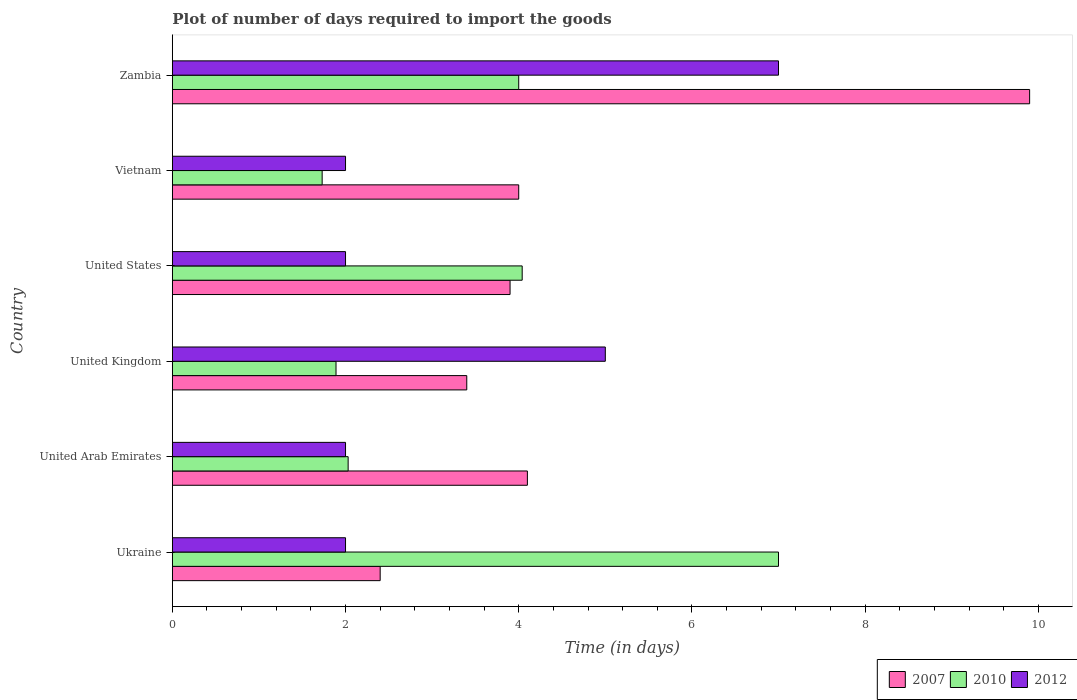How many different coloured bars are there?
Offer a very short reply. 3. How many groups of bars are there?
Make the answer very short. 6. How many bars are there on the 4th tick from the bottom?
Keep it short and to the point. 3. Across all countries, what is the maximum time required to import goods in 2012?
Your response must be concise. 7. Across all countries, what is the minimum time required to import goods in 2010?
Provide a succinct answer. 1.73. In which country was the time required to import goods in 2007 maximum?
Ensure brevity in your answer.  Zambia. In which country was the time required to import goods in 2012 minimum?
Offer a very short reply. Ukraine. What is the total time required to import goods in 2010 in the graph?
Make the answer very short. 20.69. What is the difference between the time required to import goods in 2007 in Ukraine and that in United Arab Emirates?
Keep it short and to the point. -1.7. What is the difference between the time required to import goods in 2012 in Ukraine and the time required to import goods in 2010 in Zambia?
Keep it short and to the point. -2. What is the average time required to import goods in 2012 per country?
Provide a short and direct response. 3.33. What is the difference between the time required to import goods in 2010 and time required to import goods in 2012 in Ukraine?
Offer a very short reply. 5. What is the ratio of the time required to import goods in 2010 in United Arab Emirates to that in United Kingdom?
Your answer should be compact. 1.07. Is the difference between the time required to import goods in 2010 in United States and Vietnam greater than the difference between the time required to import goods in 2012 in United States and Vietnam?
Your answer should be compact. Yes. What is the difference between the highest and the second highest time required to import goods in 2012?
Your answer should be compact. 2. What does the 1st bar from the top in United States represents?
Your response must be concise. 2012. What does the 2nd bar from the bottom in Ukraine represents?
Your response must be concise. 2010. How many bars are there?
Your answer should be compact. 18. How many countries are there in the graph?
Provide a succinct answer. 6. How many legend labels are there?
Make the answer very short. 3. How are the legend labels stacked?
Offer a terse response. Horizontal. What is the title of the graph?
Keep it short and to the point. Plot of number of days required to import the goods. Does "2004" appear as one of the legend labels in the graph?
Your answer should be compact. No. What is the label or title of the X-axis?
Your answer should be very brief. Time (in days). What is the label or title of the Y-axis?
Make the answer very short. Country. What is the Time (in days) of 2010 in United Arab Emirates?
Offer a terse response. 2.03. What is the Time (in days) in 2012 in United Arab Emirates?
Give a very brief answer. 2. What is the Time (in days) of 2010 in United Kingdom?
Make the answer very short. 1.89. What is the Time (in days) of 2007 in United States?
Your response must be concise. 3.9. What is the Time (in days) of 2010 in United States?
Offer a terse response. 4.04. What is the Time (in days) of 2012 in United States?
Offer a very short reply. 2. What is the Time (in days) in 2007 in Vietnam?
Offer a very short reply. 4. What is the Time (in days) in 2010 in Vietnam?
Your answer should be very brief. 1.73. What is the Time (in days) in 2012 in Vietnam?
Give a very brief answer. 2. Across all countries, what is the maximum Time (in days) of 2007?
Keep it short and to the point. 9.9. Across all countries, what is the maximum Time (in days) in 2012?
Make the answer very short. 7. Across all countries, what is the minimum Time (in days) of 2007?
Provide a short and direct response. 2.4. Across all countries, what is the minimum Time (in days) of 2010?
Offer a terse response. 1.73. Across all countries, what is the minimum Time (in days) of 2012?
Your answer should be very brief. 2. What is the total Time (in days) in 2007 in the graph?
Your response must be concise. 27.7. What is the total Time (in days) of 2010 in the graph?
Your answer should be compact. 20.69. What is the total Time (in days) of 2012 in the graph?
Your response must be concise. 20. What is the difference between the Time (in days) in 2007 in Ukraine and that in United Arab Emirates?
Your answer should be very brief. -1.7. What is the difference between the Time (in days) of 2010 in Ukraine and that in United Arab Emirates?
Keep it short and to the point. 4.97. What is the difference between the Time (in days) of 2012 in Ukraine and that in United Arab Emirates?
Ensure brevity in your answer.  0. What is the difference between the Time (in days) of 2010 in Ukraine and that in United Kingdom?
Ensure brevity in your answer.  5.11. What is the difference between the Time (in days) of 2007 in Ukraine and that in United States?
Ensure brevity in your answer.  -1.5. What is the difference between the Time (in days) in 2010 in Ukraine and that in United States?
Make the answer very short. 2.96. What is the difference between the Time (in days) in 2012 in Ukraine and that in United States?
Ensure brevity in your answer.  0. What is the difference between the Time (in days) in 2007 in Ukraine and that in Vietnam?
Your answer should be very brief. -1.6. What is the difference between the Time (in days) of 2010 in Ukraine and that in Vietnam?
Provide a succinct answer. 5.27. What is the difference between the Time (in days) in 2007 in United Arab Emirates and that in United Kingdom?
Provide a short and direct response. 0.7. What is the difference between the Time (in days) of 2010 in United Arab Emirates and that in United Kingdom?
Provide a short and direct response. 0.14. What is the difference between the Time (in days) of 2010 in United Arab Emirates and that in United States?
Give a very brief answer. -2.01. What is the difference between the Time (in days) of 2012 in United Arab Emirates and that in United States?
Your response must be concise. 0. What is the difference between the Time (in days) in 2012 in United Arab Emirates and that in Vietnam?
Ensure brevity in your answer.  0. What is the difference between the Time (in days) of 2010 in United Arab Emirates and that in Zambia?
Ensure brevity in your answer.  -1.97. What is the difference between the Time (in days) of 2010 in United Kingdom and that in United States?
Ensure brevity in your answer.  -2.15. What is the difference between the Time (in days) of 2010 in United Kingdom and that in Vietnam?
Offer a very short reply. 0.16. What is the difference between the Time (in days) of 2010 in United Kingdom and that in Zambia?
Your answer should be very brief. -2.11. What is the difference between the Time (in days) in 2007 in United States and that in Vietnam?
Offer a terse response. -0.1. What is the difference between the Time (in days) of 2010 in United States and that in Vietnam?
Your answer should be compact. 2.31. What is the difference between the Time (in days) in 2007 in United States and that in Zambia?
Give a very brief answer. -6. What is the difference between the Time (in days) of 2010 in United States and that in Zambia?
Ensure brevity in your answer.  0.04. What is the difference between the Time (in days) of 2010 in Vietnam and that in Zambia?
Keep it short and to the point. -2.27. What is the difference between the Time (in days) of 2012 in Vietnam and that in Zambia?
Offer a very short reply. -5. What is the difference between the Time (in days) in 2007 in Ukraine and the Time (in days) in 2010 in United Arab Emirates?
Your response must be concise. 0.37. What is the difference between the Time (in days) in 2007 in Ukraine and the Time (in days) in 2012 in United Arab Emirates?
Your answer should be compact. 0.4. What is the difference between the Time (in days) in 2007 in Ukraine and the Time (in days) in 2010 in United Kingdom?
Give a very brief answer. 0.51. What is the difference between the Time (in days) of 2007 in Ukraine and the Time (in days) of 2012 in United Kingdom?
Make the answer very short. -2.6. What is the difference between the Time (in days) in 2007 in Ukraine and the Time (in days) in 2010 in United States?
Provide a short and direct response. -1.64. What is the difference between the Time (in days) in 2007 in Ukraine and the Time (in days) in 2010 in Vietnam?
Make the answer very short. 0.67. What is the difference between the Time (in days) in 2007 in United Arab Emirates and the Time (in days) in 2010 in United Kingdom?
Give a very brief answer. 2.21. What is the difference between the Time (in days) in 2010 in United Arab Emirates and the Time (in days) in 2012 in United Kingdom?
Your answer should be very brief. -2.97. What is the difference between the Time (in days) in 2007 in United Arab Emirates and the Time (in days) in 2010 in United States?
Provide a short and direct response. 0.06. What is the difference between the Time (in days) of 2010 in United Arab Emirates and the Time (in days) of 2012 in United States?
Your response must be concise. 0.03. What is the difference between the Time (in days) of 2007 in United Arab Emirates and the Time (in days) of 2010 in Vietnam?
Offer a terse response. 2.37. What is the difference between the Time (in days) of 2007 in United Arab Emirates and the Time (in days) of 2012 in Vietnam?
Your answer should be compact. 2.1. What is the difference between the Time (in days) in 2010 in United Arab Emirates and the Time (in days) in 2012 in Zambia?
Provide a short and direct response. -4.97. What is the difference between the Time (in days) of 2007 in United Kingdom and the Time (in days) of 2010 in United States?
Your answer should be very brief. -0.64. What is the difference between the Time (in days) in 2010 in United Kingdom and the Time (in days) in 2012 in United States?
Ensure brevity in your answer.  -0.11. What is the difference between the Time (in days) in 2007 in United Kingdom and the Time (in days) in 2010 in Vietnam?
Provide a succinct answer. 1.67. What is the difference between the Time (in days) in 2007 in United Kingdom and the Time (in days) in 2012 in Vietnam?
Make the answer very short. 1.4. What is the difference between the Time (in days) of 2010 in United Kingdom and the Time (in days) of 2012 in Vietnam?
Give a very brief answer. -0.11. What is the difference between the Time (in days) in 2010 in United Kingdom and the Time (in days) in 2012 in Zambia?
Give a very brief answer. -5.11. What is the difference between the Time (in days) in 2007 in United States and the Time (in days) in 2010 in Vietnam?
Give a very brief answer. 2.17. What is the difference between the Time (in days) of 2007 in United States and the Time (in days) of 2012 in Vietnam?
Your response must be concise. 1.9. What is the difference between the Time (in days) of 2010 in United States and the Time (in days) of 2012 in Vietnam?
Give a very brief answer. 2.04. What is the difference between the Time (in days) of 2007 in United States and the Time (in days) of 2012 in Zambia?
Make the answer very short. -3.1. What is the difference between the Time (in days) in 2010 in United States and the Time (in days) in 2012 in Zambia?
Provide a short and direct response. -2.96. What is the difference between the Time (in days) in 2010 in Vietnam and the Time (in days) in 2012 in Zambia?
Keep it short and to the point. -5.27. What is the average Time (in days) of 2007 per country?
Give a very brief answer. 4.62. What is the average Time (in days) in 2010 per country?
Your answer should be compact. 3.45. What is the difference between the Time (in days) of 2007 and Time (in days) of 2012 in Ukraine?
Provide a succinct answer. 0.4. What is the difference between the Time (in days) of 2010 and Time (in days) of 2012 in Ukraine?
Offer a terse response. 5. What is the difference between the Time (in days) of 2007 and Time (in days) of 2010 in United Arab Emirates?
Keep it short and to the point. 2.07. What is the difference between the Time (in days) of 2007 and Time (in days) of 2012 in United Arab Emirates?
Keep it short and to the point. 2.1. What is the difference between the Time (in days) in 2010 and Time (in days) in 2012 in United Arab Emirates?
Your answer should be compact. 0.03. What is the difference between the Time (in days) in 2007 and Time (in days) in 2010 in United Kingdom?
Give a very brief answer. 1.51. What is the difference between the Time (in days) of 2010 and Time (in days) of 2012 in United Kingdom?
Provide a short and direct response. -3.11. What is the difference between the Time (in days) in 2007 and Time (in days) in 2010 in United States?
Your response must be concise. -0.14. What is the difference between the Time (in days) in 2007 and Time (in days) in 2012 in United States?
Keep it short and to the point. 1.9. What is the difference between the Time (in days) of 2010 and Time (in days) of 2012 in United States?
Offer a terse response. 2.04. What is the difference between the Time (in days) of 2007 and Time (in days) of 2010 in Vietnam?
Provide a short and direct response. 2.27. What is the difference between the Time (in days) in 2007 and Time (in days) in 2012 in Vietnam?
Ensure brevity in your answer.  2. What is the difference between the Time (in days) of 2010 and Time (in days) of 2012 in Vietnam?
Provide a short and direct response. -0.27. What is the difference between the Time (in days) of 2007 and Time (in days) of 2010 in Zambia?
Keep it short and to the point. 5.9. What is the difference between the Time (in days) of 2007 and Time (in days) of 2012 in Zambia?
Keep it short and to the point. 2.9. What is the ratio of the Time (in days) of 2007 in Ukraine to that in United Arab Emirates?
Your answer should be compact. 0.59. What is the ratio of the Time (in days) in 2010 in Ukraine to that in United Arab Emirates?
Your answer should be compact. 3.45. What is the ratio of the Time (in days) of 2012 in Ukraine to that in United Arab Emirates?
Make the answer very short. 1. What is the ratio of the Time (in days) in 2007 in Ukraine to that in United Kingdom?
Keep it short and to the point. 0.71. What is the ratio of the Time (in days) of 2010 in Ukraine to that in United Kingdom?
Provide a short and direct response. 3.7. What is the ratio of the Time (in days) in 2007 in Ukraine to that in United States?
Your response must be concise. 0.62. What is the ratio of the Time (in days) in 2010 in Ukraine to that in United States?
Offer a terse response. 1.73. What is the ratio of the Time (in days) of 2012 in Ukraine to that in United States?
Your answer should be very brief. 1. What is the ratio of the Time (in days) of 2010 in Ukraine to that in Vietnam?
Your answer should be compact. 4.05. What is the ratio of the Time (in days) in 2007 in Ukraine to that in Zambia?
Your answer should be very brief. 0.24. What is the ratio of the Time (in days) in 2012 in Ukraine to that in Zambia?
Make the answer very short. 0.29. What is the ratio of the Time (in days) of 2007 in United Arab Emirates to that in United Kingdom?
Your answer should be compact. 1.21. What is the ratio of the Time (in days) in 2010 in United Arab Emirates to that in United Kingdom?
Offer a terse response. 1.07. What is the ratio of the Time (in days) in 2012 in United Arab Emirates to that in United Kingdom?
Make the answer very short. 0.4. What is the ratio of the Time (in days) in 2007 in United Arab Emirates to that in United States?
Provide a succinct answer. 1.05. What is the ratio of the Time (in days) in 2010 in United Arab Emirates to that in United States?
Provide a short and direct response. 0.5. What is the ratio of the Time (in days) of 2007 in United Arab Emirates to that in Vietnam?
Offer a terse response. 1.02. What is the ratio of the Time (in days) in 2010 in United Arab Emirates to that in Vietnam?
Offer a very short reply. 1.17. What is the ratio of the Time (in days) of 2012 in United Arab Emirates to that in Vietnam?
Your response must be concise. 1. What is the ratio of the Time (in days) of 2007 in United Arab Emirates to that in Zambia?
Ensure brevity in your answer.  0.41. What is the ratio of the Time (in days) in 2010 in United Arab Emirates to that in Zambia?
Offer a terse response. 0.51. What is the ratio of the Time (in days) of 2012 in United Arab Emirates to that in Zambia?
Your answer should be compact. 0.29. What is the ratio of the Time (in days) in 2007 in United Kingdom to that in United States?
Your response must be concise. 0.87. What is the ratio of the Time (in days) in 2010 in United Kingdom to that in United States?
Provide a succinct answer. 0.47. What is the ratio of the Time (in days) of 2007 in United Kingdom to that in Vietnam?
Your answer should be compact. 0.85. What is the ratio of the Time (in days) of 2010 in United Kingdom to that in Vietnam?
Your answer should be compact. 1.09. What is the ratio of the Time (in days) of 2012 in United Kingdom to that in Vietnam?
Give a very brief answer. 2.5. What is the ratio of the Time (in days) in 2007 in United Kingdom to that in Zambia?
Offer a very short reply. 0.34. What is the ratio of the Time (in days) in 2010 in United Kingdom to that in Zambia?
Provide a short and direct response. 0.47. What is the ratio of the Time (in days) in 2010 in United States to that in Vietnam?
Your answer should be compact. 2.34. What is the ratio of the Time (in days) in 2012 in United States to that in Vietnam?
Make the answer very short. 1. What is the ratio of the Time (in days) in 2007 in United States to that in Zambia?
Provide a succinct answer. 0.39. What is the ratio of the Time (in days) of 2010 in United States to that in Zambia?
Your answer should be very brief. 1.01. What is the ratio of the Time (in days) of 2012 in United States to that in Zambia?
Your answer should be compact. 0.29. What is the ratio of the Time (in days) of 2007 in Vietnam to that in Zambia?
Your response must be concise. 0.4. What is the ratio of the Time (in days) in 2010 in Vietnam to that in Zambia?
Offer a very short reply. 0.43. What is the ratio of the Time (in days) in 2012 in Vietnam to that in Zambia?
Give a very brief answer. 0.29. What is the difference between the highest and the second highest Time (in days) of 2010?
Give a very brief answer. 2.96. What is the difference between the highest and the lowest Time (in days) of 2007?
Make the answer very short. 7.5. What is the difference between the highest and the lowest Time (in days) of 2010?
Your response must be concise. 5.27. 